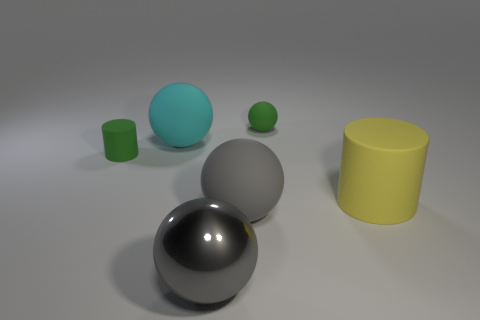Can you tell me which objects appear to have a reflective surface and what they might be reflecting? Of all the objects presented, the large black sphere in the foreground has a highly reflective surface. It appears to be reflecting the environment around it, which includes the white ceiling and the other objects nearby. The reflections on its surface suggest a softly lit room with a broad light source, as evidenced by the highlights and the muted reflections of the other objects in the room.  Are there any shadows in the image, and what do they tell us about the light source? Yes, there are shadows cast by each object indicating a single diffused light source coming from the upper left of the frame. The shadows are soft-edged, which suggests the light source is not only diffused but possibly also quite large relative to the size of the objects. The positioning of the shadows helps to add depth to the image and gives clues about the spatial relationships between the objects. 